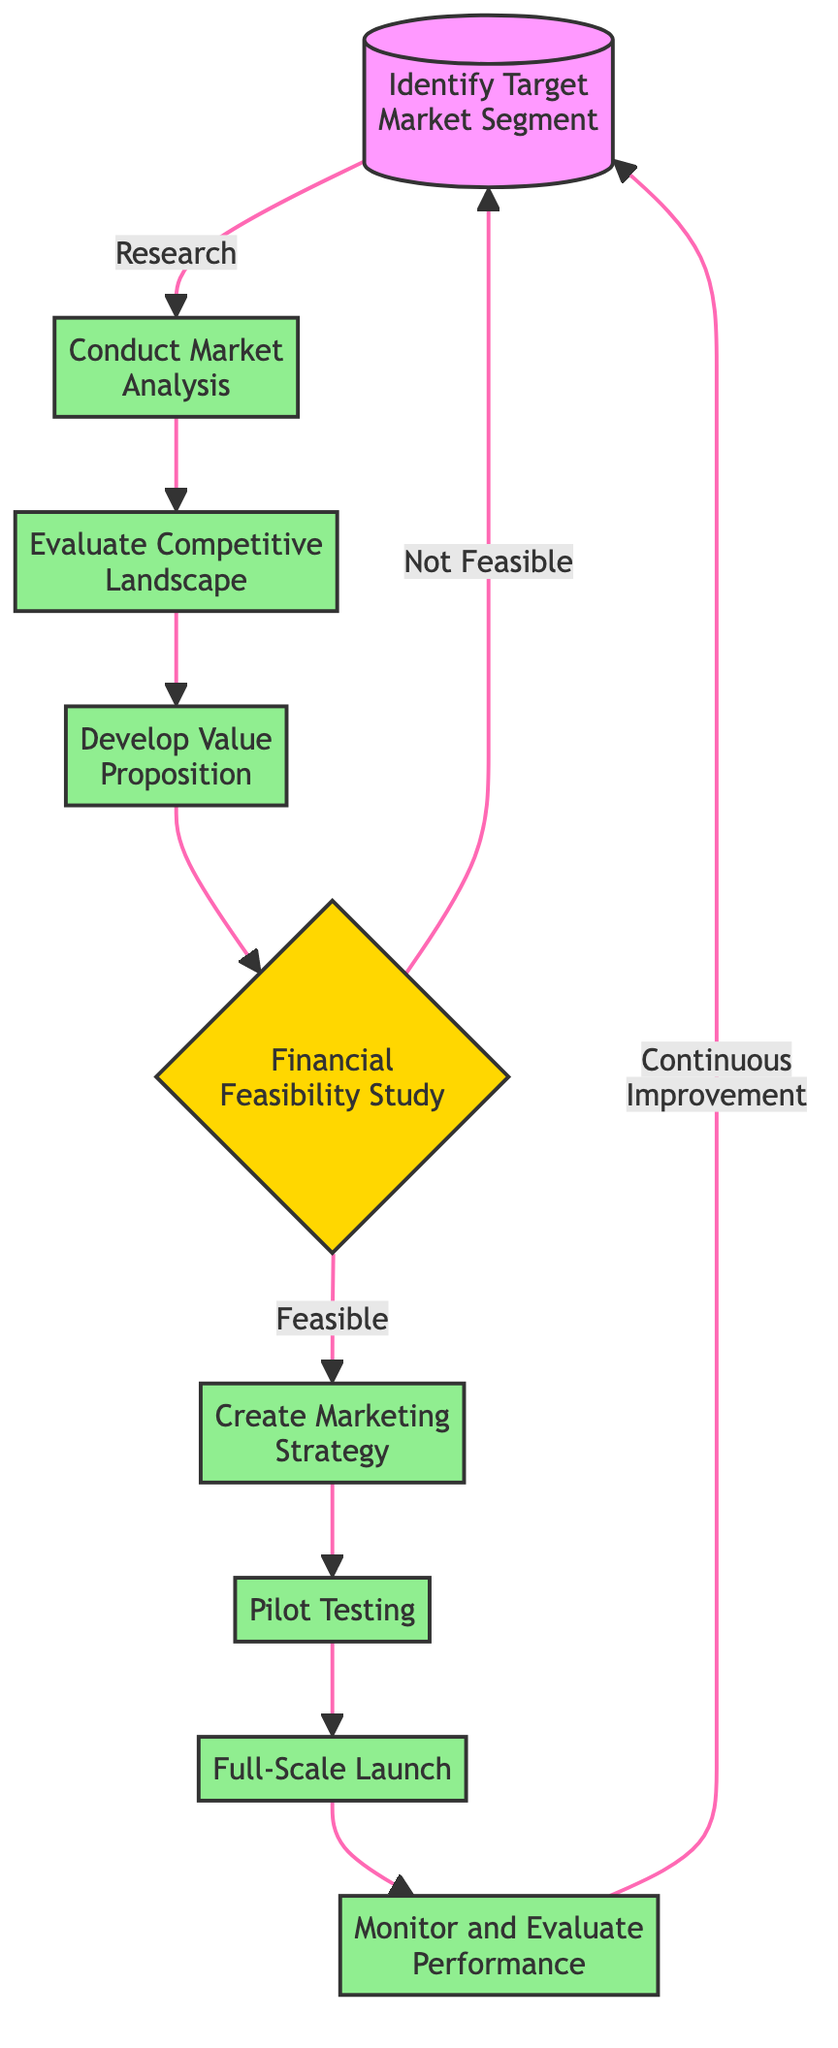What is the first step in the decision-making process? The first step in the flowchart is represented by the node labeled "Identify Target Market Segment," indicating it is the initial action to take.
Answer: Identify Target Market Segment How many nodes are there in the flowchart? There are 9 nodes in total, each representing a distinct step in the decision-making process for market expansion.
Answer: 9 What action follows "Conduct Market Analysis"? The flowchart indicates that after "Conduct Market Analysis," the next step is "Evaluate Competitive Landscape," showing the direct flow from one action to the next.
Answer: Evaluate Competitive Landscape What happens if the Financial Feasibility Study is deemed not feasible? In the flowchart, if the Financial Feasibility Study is assessed as "Not Feasible," the process loops back to the first step, which is "Identify Target Market Segment," indicating a reconsideration of the emerging market.
Answer: Identify Target Market Segment What is the final step in the flowchart? The last action in the flowchart is "Monitor and Evaluate Performance," which is intended to ensure continued success and improvements after the full-scale launch.
Answer: Monitor and Evaluate Performance What are the steps leading to the Full-Scale Launch? The steps leading to "Full-Scale Launch" are: "Create Marketing Strategy" and "Pilot Testing" in that order, indicating that these actions build upon each other leading to the launch.
Answer: Create Marketing Strategy, Pilot Testing How many decision points are there in the flowchart? There is only one decision point in the flowchart, which occurs at the "Financial Feasibility Study" node where the determination of feasibility takes place.
Answer: 1 What is the main purpose of the "Monitor and Evaluate Performance" step? The main purpose of this step is to continuously track market performance and customer feedback in order to inform ongoing adjustments in the strategy.
Answer: Continuous tracking What would be the next action after "Pilot Testing"? The action following "Pilot Testing" in the flowchart is "Full-Scale Launch," which signifies implementing the plan based on pilot results.
Answer: Full-Scale Launch 